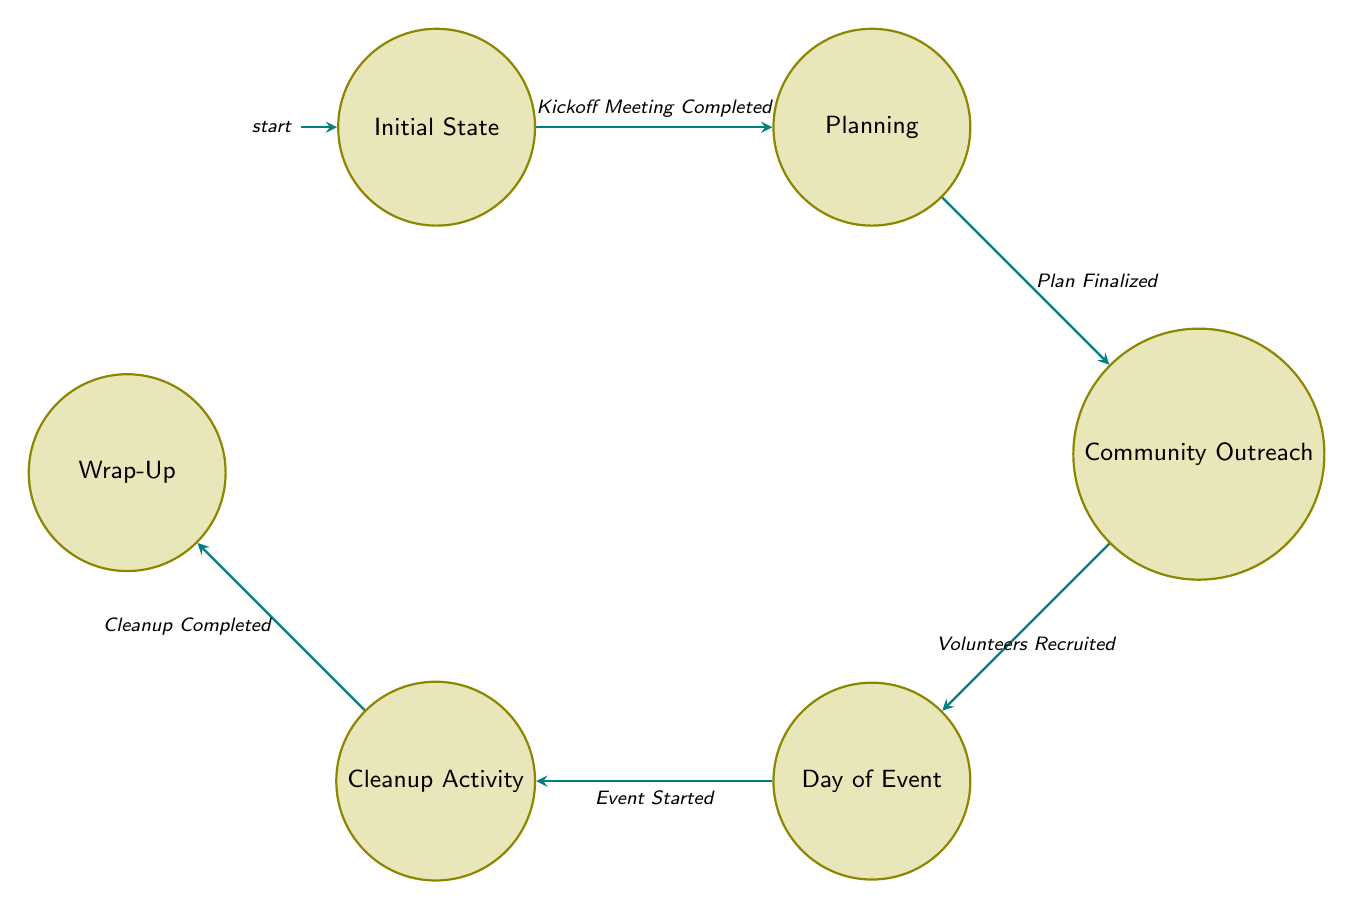What is the first action in the process? The diagram initiates with the "Initial State," where the action described is "Kickoff Meeting." Thus, the first action is the one performed at the first state.
Answer: Kickoff Meeting How many states are there in the diagram? By counting the states labeled in the diagram, there are a total of six distinct states present.
Answer: 6 What transition follows the "Planning" state? The "Planning" state transitions to the "Community Outreach" state when the trigger "Plan Finalized" occurs. This indicates the flow from one state to another in the FSM.
Answer: Community Outreach What actions are involved in the "Wrap-Up" state? The "Wrap-Up" state encompasses three actions: "Collect Supplies," "Thank Volunteers," and "Report Results." These actions define what happens during this state of the process.
Answer: Collect Supplies, Thank Volunteers, Report Results What is the final state in the sequence? Following the flow from the initial state through to the end, the last state reached is the "Wrap-Up," which concludes the event's organization process.
Answer: Wrap-Up What triggers the transition from "Day of Event" to "Cleanup Activity"? The transition between these two states is triggered by the event starting, represented by the trigger labeled "Event Started," indicating the moment preparations give way to the cleanup.
Answer: Event Started Which state comes after "Community Outreach"? After completing the "Community Outreach" state, the next state that the flow progresses to is "Day of Event," following the specific trigger noted earlier in the diagram.
Answer: Day of Event What action must occur for the transition from "Cleanup Activity" to "Wrap-Up"? To transition from "Cleanup Activity" to "Wrap-Up," the condition that must be met is the "Cleanup Completed," which signals that the cleaning process is finished.
Answer: Cleanup Completed 